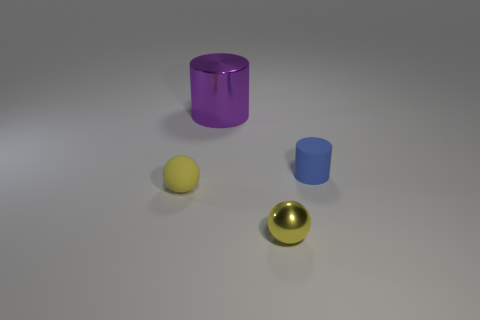Is there a tiny shiny object that has the same color as the tiny rubber sphere?
Give a very brief answer. Yes. Is the color of the rubber thing that is in front of the rubber cylinder the same as the small object that is on the right side of the tiny shiny sphere?
Offer a terse response. No. What number of matte objects are either tiny yellow spheres or large cyan things?
Give a very brief answer. 1. The metal thing that is behind the tiny yellow sphere right of the cylinder behind the blue matte cylinder is what color?
Provide a succinct answer. Purple. There is a tiny rubber thing that is the same shape as the tiny yellow metal thing; what color is it?
Give a very brief answer. Yellow. Is there anything else of the same color as the tiny shiny ball?
Provide a short and direct response. Yes. How many other things are the same material as the big thing?
Give a very brief answer. 1. What size is the yellow matte thing?
Provide a succinct answer. Small. Is there a purple object of the same shape as the tiny blue rubber thing?
Give a very brief answer. Yes. What number of things are either tiny cylinders or small yellow balls that are in front of the small blue matte object?
Your answer should be very brief. 3. 